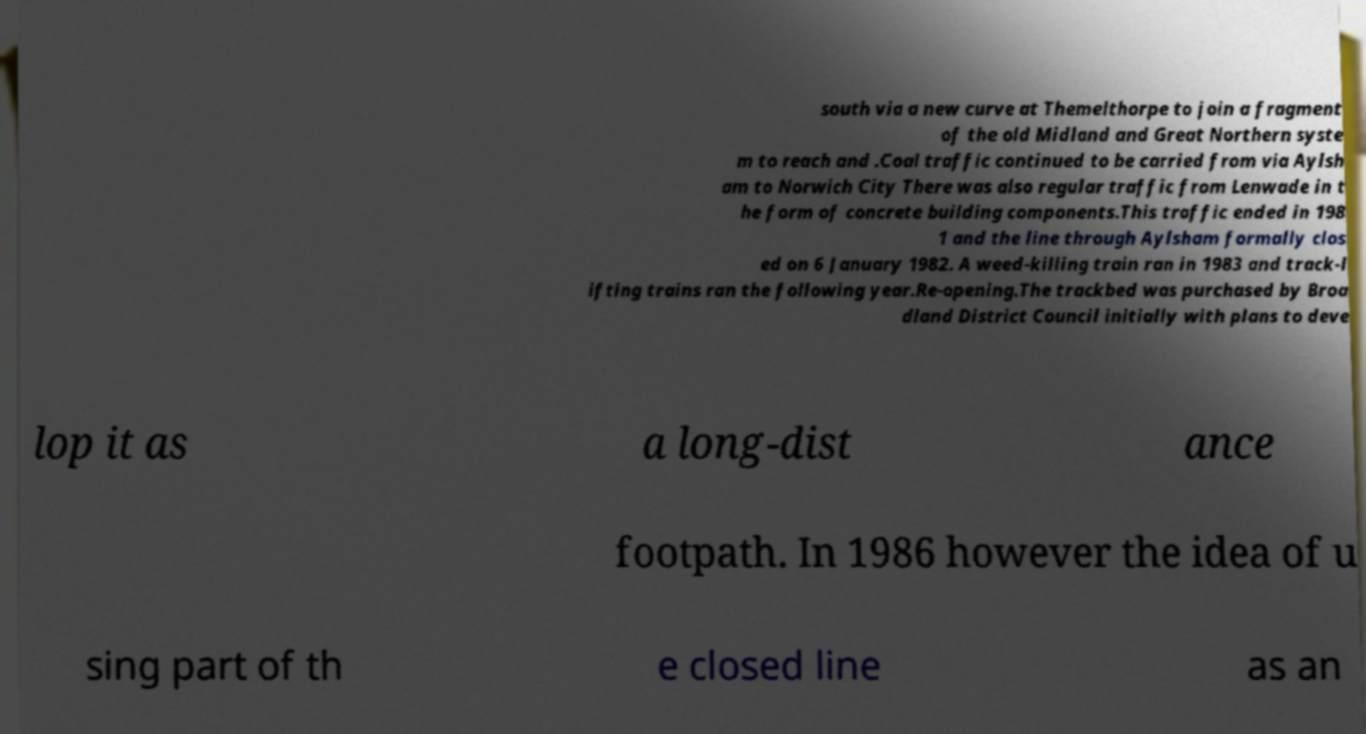I need the written content from this picture converted into text. Can you do that? south via a new curve at Themelthorpe to join a fragment of the old Midland and Great Northern syste m to reach and .Coal traffic continued to be carried from via Aylsh am to Norwich City There was also regular traffic from Lenwade in t he form of concrete building components.This traffic ended in 198 1 and the line through Aylsham formally clos ed on 6 January 1982. A weed-killing train ran in 1983 and track-l ifting trains ran the following year.Re-opening.The trackbed was purchased by Broa dland District Council initially with plans to deve lop it as a long-dist ance footpath. In 1986 however the idea of u sing part of th e closed line as an 